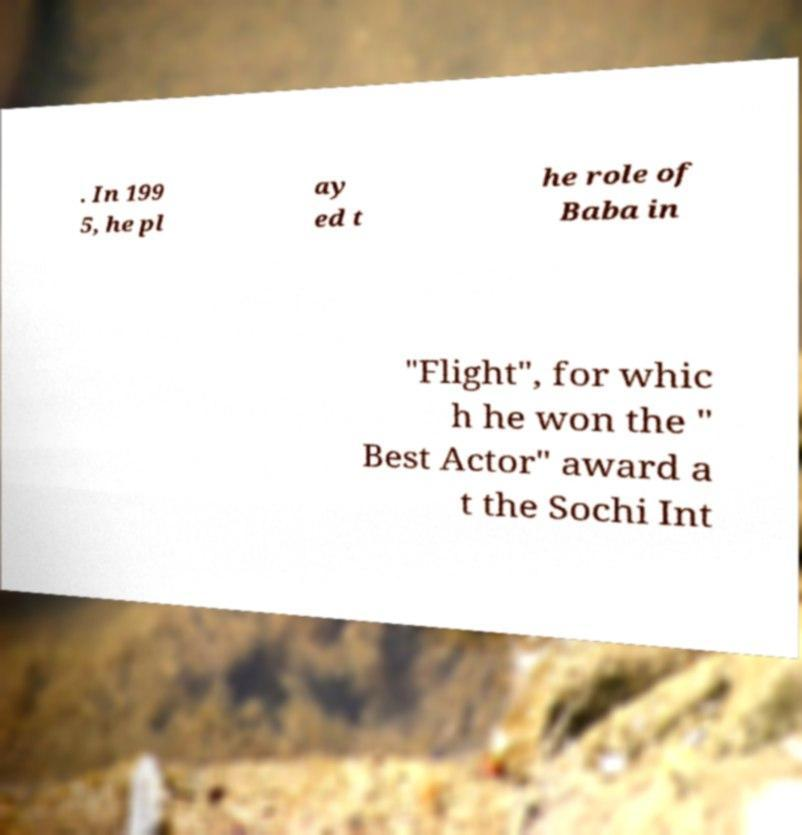There's text embedded in this image that I need extracted. Can you transcribe it verbatim? . In 199 5, he pl ay ed t he role of Baba in "Flight", for whic h he won the " Best Actor" award a t the Sochi Int 